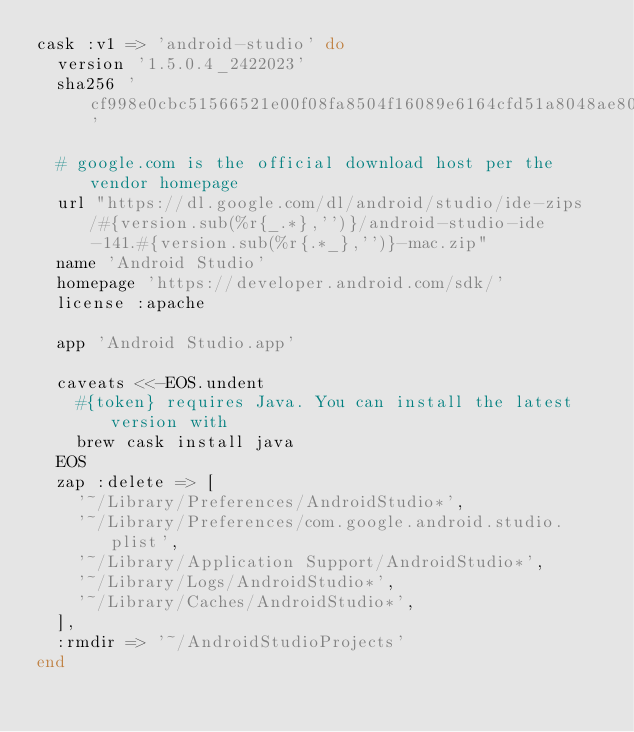<code> <loc_0><loc_0><loc_500><loc_500><_Ruby_>cask :v1 => 'android-studio' do
  version '1.5.0.4_2422023'
  sha256 'cf998e0cbc51566521e00f08fa8504f16089e6164cfd51a8048ae800f27954ac'

  # google.com is the official download host per the vendor homepage
  url "https://dl.google.com/dl/android/studio/ide-zips/#{version.sub(%r{_.*},'')}/android-studio-ide-141.#{version.sub(%r{.*_},'')}-mac.zip"
  name 'Android Studio'
  homepage 'https://developer.android.com/sdk/'
  license :apache

  app 'Android Studio.app'

  caveats <<-EOS.undent
    #{token} requires Java. You can install the latest version with
    brew cask install java
  EOS
  zap :delete => [
    '~/Library/Preferences/AndroidStudio*',
    '~/Library/Preferences/com.google.android.studio.plist',
    '~/Library/Application Support/AndroidStudio*',
    '~/Library/Logs/AndroidStudio*',
    '~/Library/Caches/AndroidStudio*',
  ],
  :rmdir => '~/AndroidStudioProjects'
end
</code> 